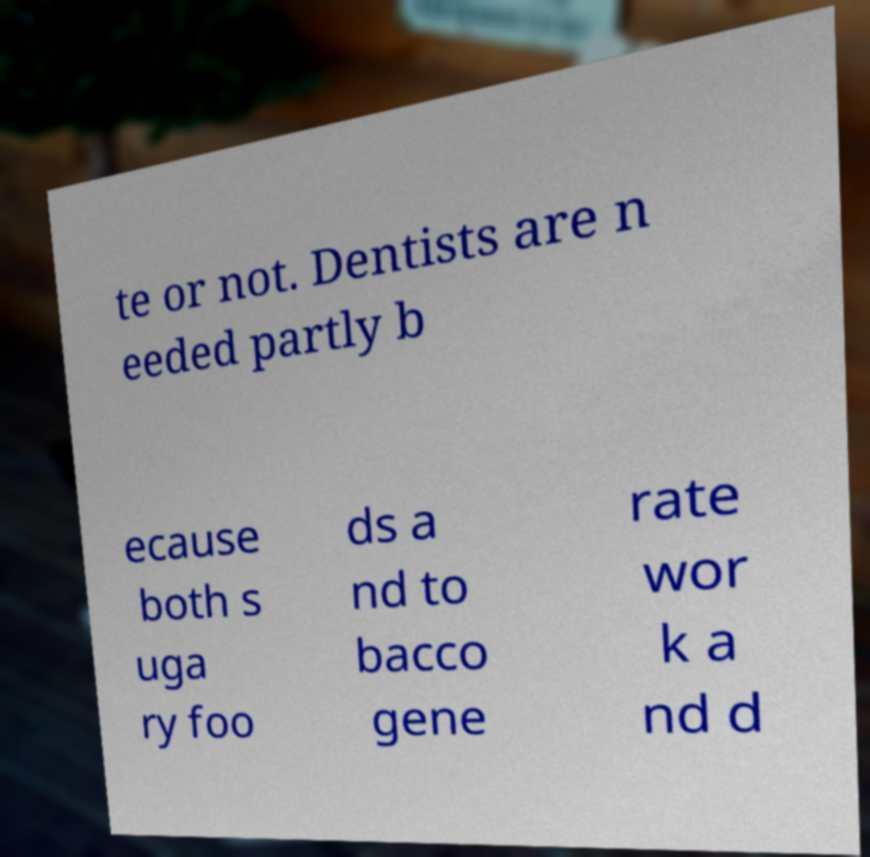Please identify and transcribe the text found in this image. te or not. Dentists are n eeded partly b ecause both s uga ry foo ds a nd to bacco gene rate wor k a nd d 